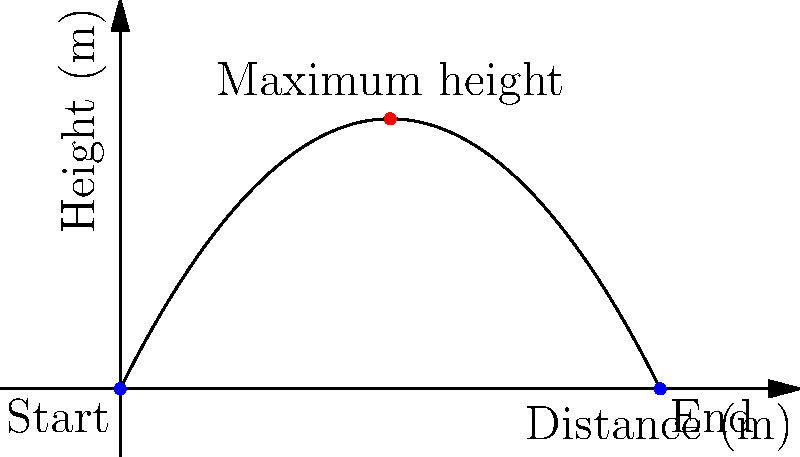At a local playground, a child throws a ball that follows a parabolic path. The ball's trajectory is described by the equation $h(x) = -0.2x^2 + 2x$, where $h$ is the height in meters and $x$ is the horizontal distance in meters. What is the maximum height reached by the ball, and at what horizontal distance does this occur? To find the maximum height and its corresponding horizontal distance:

1) The maximum point of a parabola occurs at the vertex.
2) For a quadratic function $f(x) = ax^2 + bx + c$, the x-coordinate of the vertex is given by $x = -\frac{b}{2a}$.
3) In our equation $h(x) = -0.2x^2 + 2x$, we have $a = -0.2$ and $b = 2$.
4) Substituting into the formula:
   $x = -\frac{2}{2(-0.2)} = -\frac{2}{-0.4} = 5$ meters
5) To find the maximum height, we substitute $x = 5$ into the original equation:
   $h(5) = -0.2(5)^2 + 2(5) = -0.2(25) + 10 = -5 + 10 = 5$ meters

Therefore, the ball reaches its maximum height of 5 meters at a horizontal distance of 5 meters.
Answer: 5 meters high at 5 meters horizontal distance 